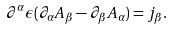<formula> <loc_0><loc_0><loc_500><loc_500>\partial ^ { \alpha } \epsilon ( \partial _ { \alpha } A _ { \beta } - \partial _ { \beta } A _ { \alpha } ) = j _ { \beta } .</formula> 